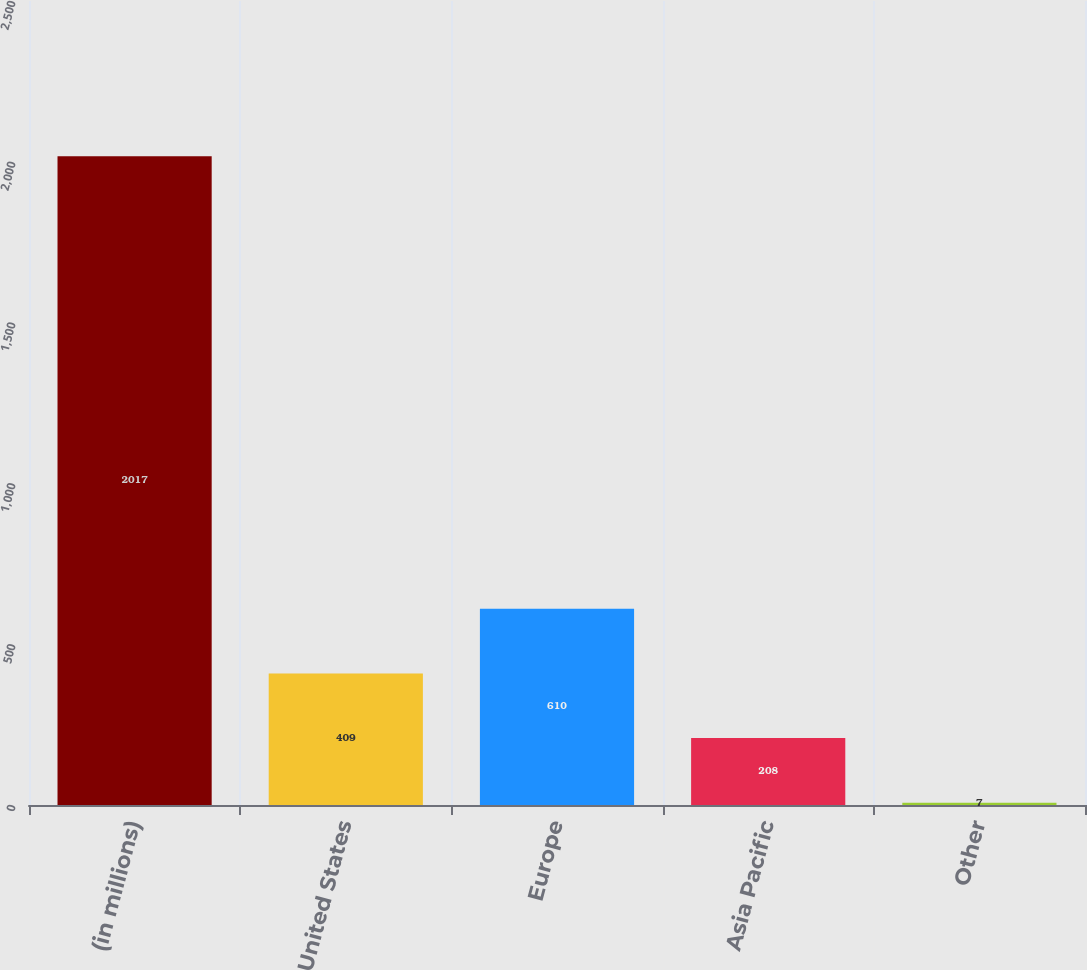Convert chart. <chart><loc_0><loc_0><loc_500><loc_500><bar_chart><fcel>(in millions)<fcel>United States<fcel>Europe<fcel>Asia Pacific<fcel>Other<nl><fcel>2017<fcel>409<fcel>610<fcel>208<fcel>7<nl></chart> 